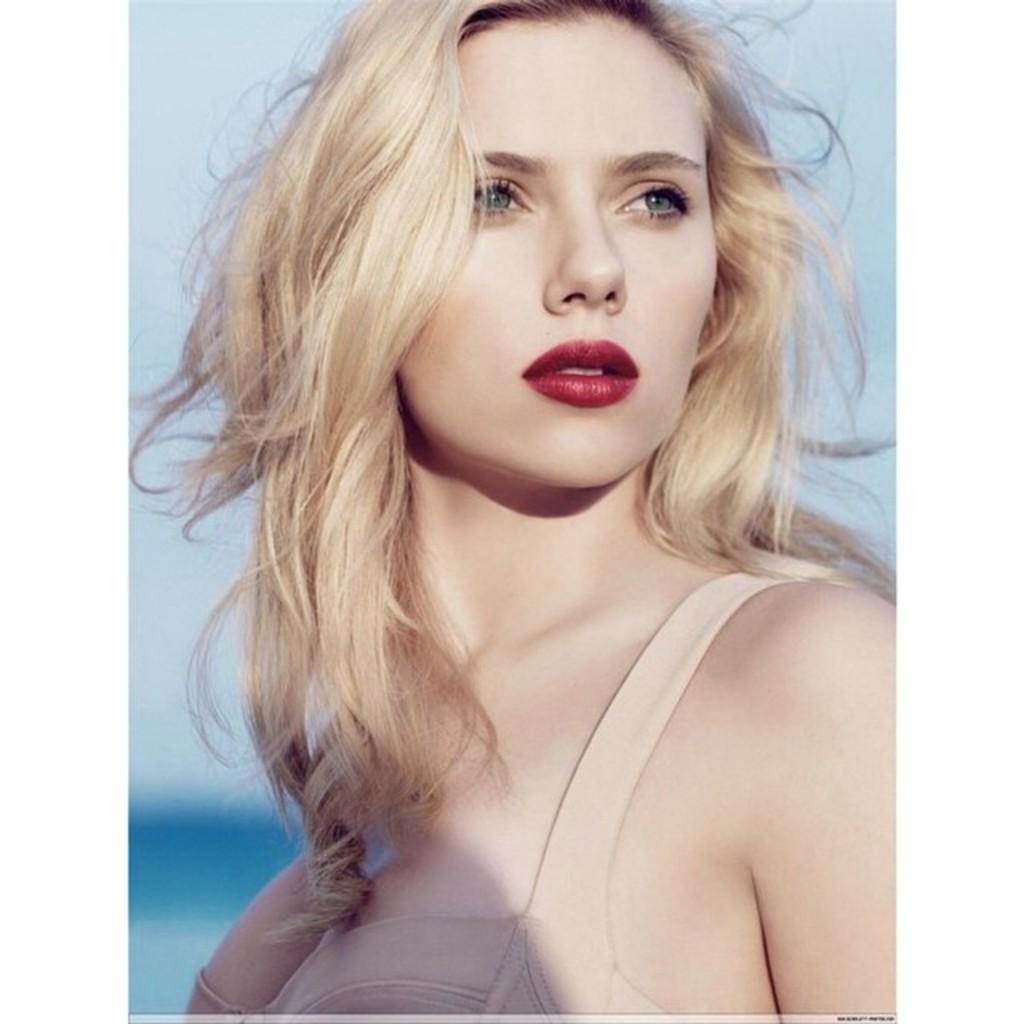Could you give a brief overview of what you see in this image? In this image in the center there is one woman who is standing, in the background there is sky. 